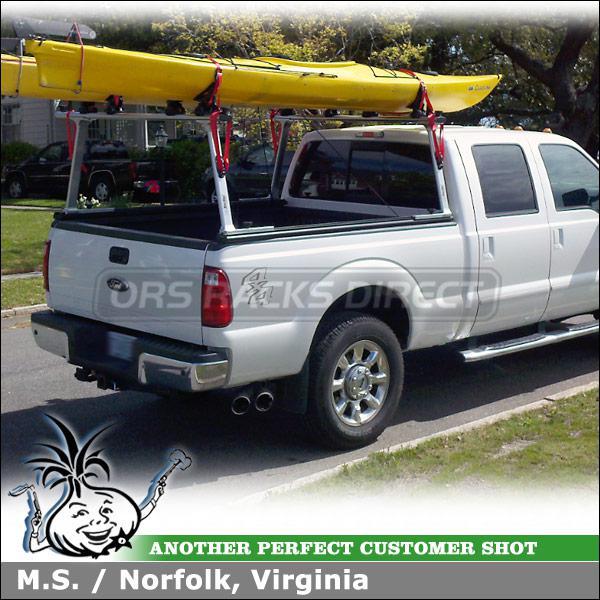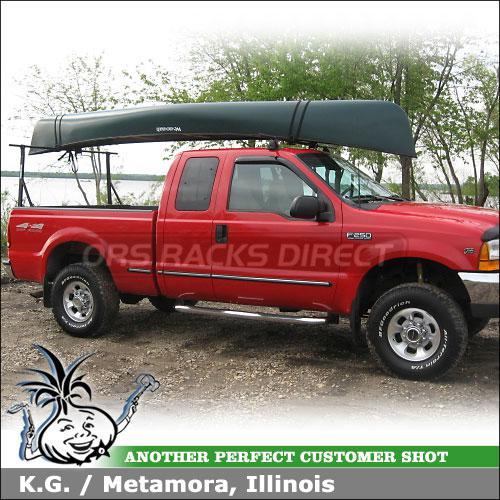The first image is the image on the left, the second image is the image on the right. For the images shown, is this caption "A body of water is visible behind a truck" true? Answer yes or no. Yes. 